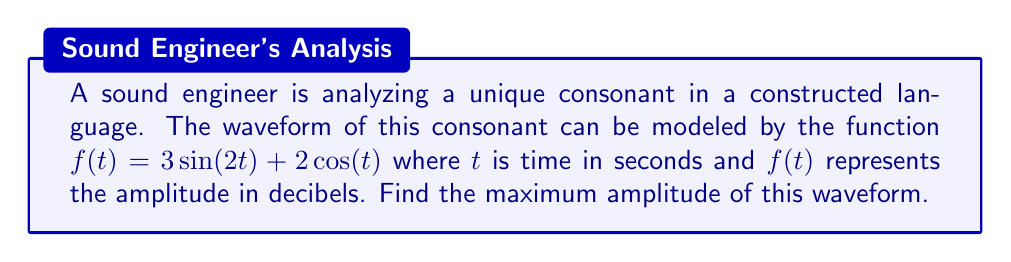Can you solve this math problem? To find the maximum amplitude, we need to find the maximum value of the function $f(t) = 3\sin(2t) + 2\cos(t)$. We can do this using the following steps:

1) First, we need to rewrite the function in the form $A\sin(t + \phi)$, where $A$ is the amplitude and $\phi$ is the phase shift.

2) We can use the trigonometric identity:
   $a\sin(bt) + c\cos(dt) = \sqrt{a^2 + c^2}\sin(dt + \arctan(\frac{a}{c}\cdot\frac{d}{b}))$

3) In our case, $a=3$, $b=2$, $c=2$, and $d=1$. Let's substitute these values:

   $3\sin(2t) + 2\cos(t) = \sqrt{3^2 + 2^2}\sin(t + \arctan(\frac{3}{2}\cdot\frac{1}{2}))$

4) Simplify:
   $= \sqrt{9 + 4}\sin(t + \arctan(\frac{3}{4}))$
   $= \sqrt{13}\sin(t + \arctan(\frac{3}{4}))$

5) The amplitude of this waveform is the coefficient of the sine function, which is $\sqrt{13}$.

Therefore, the maximum amplitude of the waveform is $\sqrt{13}$ decibels.
Answer: $\sqrt{13}$ decibels 